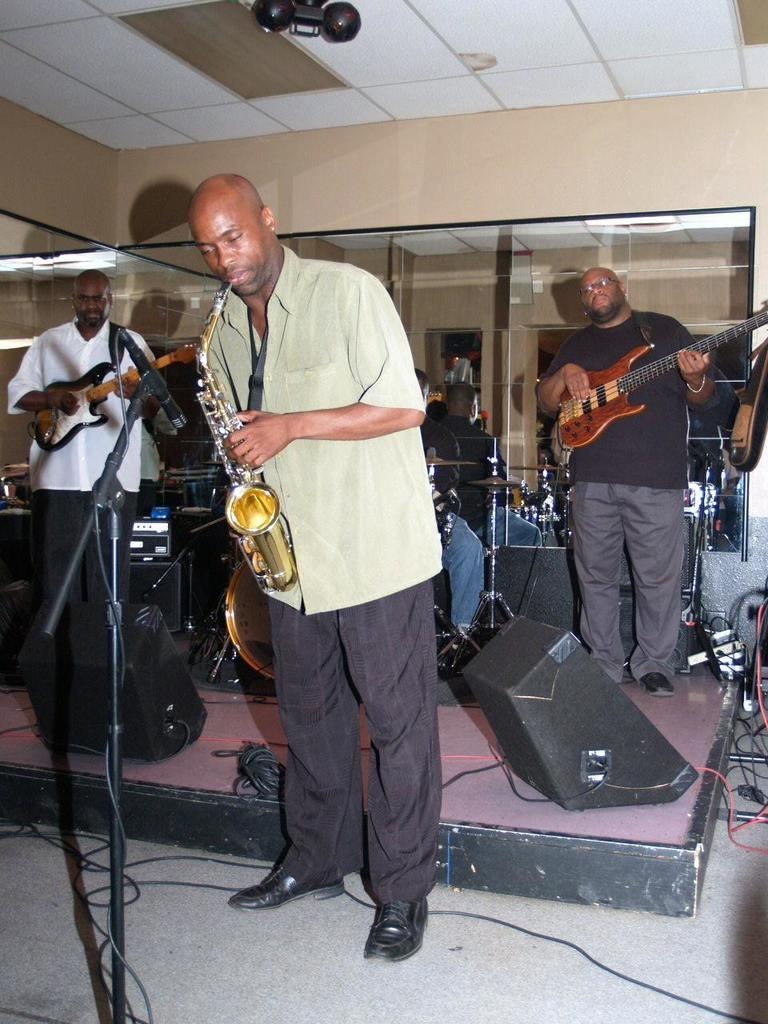What are the persons in the image doing? The persons in the image are playing musical instruments. Where are the persons located in the image? The persons are standing on the floor. What other object can be seen in the image? There is a mirror in the image. What type of apparel is the slope wearing in the image? There is no slope or apparel present in the image; it features persons playing musical instruments and a mirror. 